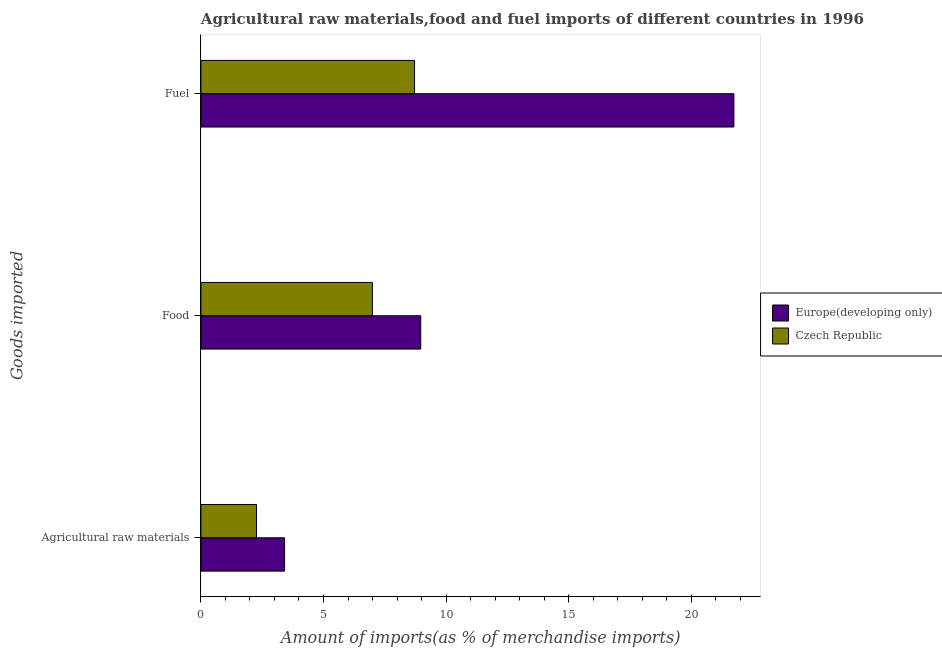Are the number of bars per tick equal to the number of legend labels?
Your answer should be very brief. Yes. Are the number of bars on each tick of the Y-axis equal?
Provide a succinct answer. Yes. What is the label of the 1st group of bars from the top?
Offer a very short reply. Fuel. What is the percentage of raw materials imports in Czech Republic?
Offer a very short reply. 2.27. Across all countries, what is the maximum percentage of fuel imports?
Provide a short and direct response. 21.74. Across all countries, what is the minimum percentage of raw materials imports?
Keep it short and to the point. 2.27. In which country was the percentage of food imports maximum?
Offer a terse response. Europe(developing only). In which country was the percentage of food imports minimum?
Offer a terse response. Czech Republic. What is the total percentage of fuel imports in the graph?
Provide a short and direct response. 30.45. What is the difference between the percentage of fuel imports in Europe(developing only) and that in Czech Republic?
Your answer should be compact. 13.03. What is the difference between the percentage of fuel imports in Czech Republic and the percentage of food imports in Europe(developing only)?
Give a very brief answer. -0.25. What is the average percentage of food imports per country?
Your response must be concise. 7.98. What is the difference between the percentage of food imports and percentage of raw materials imports in Europe(developing only)?
Your answer should be very brief. 5.55. What is the ratio of the percentage of food imports in Europe(developing only) to that in Czech Republic?
Provide a succinct answer. 1.28. Is the percentage of fuel imports in Czech Republic less than that in Europe(developing only)?
Ensure brevity in your answer.  Yes. Is the difference between the percentage of food imports in Czech Republic and Europe(developing only) greater than the difference between the percentage of raw materials imports in Czech Republic and Europe(developing only)?
Provide a succinct answer. No. What is the difference between the highest and the second highest percentage of fuel imports?
Give a very brief answer. 13.03. What is the difference between the highest and the lowest percentage of food imports?
Provide a succinct answer. 1.97. In how many countries, is the percentage of fuel imports greater than the average percentage of fuel imports taken over all countries?
Offer a very short reply. 1. Is the sum of the percentage of food imports in Europe(developing only) and Czech Republic greater than the maximum percentage of raw materials imports across all countries?
Make the answer very short. Yes. What does the 2nd bar from the top in Fuel represents?
Ensure brevity in your answer.  Europe(developing only). What does the 2nd bar from the bottom in Food represents?
Make the answer very short. Czech Republic. Are all the bars in the graph horizontal?
Provide a short and direct response. Yes. How many countries are there in the graph?
Offer a terse response. 2. What is the difference between two consecutive major ticks on the X-axis?
Provide a succinct answer. 5. Are the values on the major ticks of X-axis written in scientific E-notation?
Ensure brevity in your answer.  No. Does the graph contain any zero values?
Give a very brief answer. No. Does the graph contain grids?
Offer a very short reply. No. How many legend labels are there?
Provide a short and direct response. 2. What is the title of the graph?
Your response must be concise. Agricultural raw materials,food and fuel imports of different countries in 1996. What is the label or title of the X-axis?
Make the answer very short. Amount of imports(as % of merchandise imports). What is the label or title of the Y-axis?
Your response must be concise. Goods imported. What is the Amount of imports(as % of merchandise imports) of Europe(developing only) in Agricultural raw materials?
Offer a terse response. 3.41. What is the Amount of imports(as % of merchandise imports) of Czech Republic in Agricultural raw materials?
Keep it short and to the point. 2.27. What is the Amount of imports(as % of merchandise imports) in Europe(developing only) in Food?
Offer a very short reply. 8.97. What is the Amount of imports(as % of merchandise imports) in Czech Republic in Food?
Give a very brief answer. 6.99. What is the Amount of imports(as % of merchandise imports) in Europe(developing only) in Fuel?
Offer a terse response. 21.74. What is the Amount of imports(as % of merchandise imports) in Czech Republic in Fuel?
Make the answer very short. 8.71. Across all Goods imported, what is the maximum Amount of imports(as % of merchandise imports) in Europe(developing only)?
Provide a succinct answer. 21.74. Across all Goods imported, what is the maximum Amount of imports(as % of merchandise imports) of Czech Republic?
Ensure brevity in your answer.  8.71. Across all Goods imported, what is the minimum Amount of imports(as % of merchandise imports) in Europe(developing only)?
Make the answer very short. 3.41. Across all Goods imported, what is the minimum Amount of imports(as % of merchandise imports) in Czech Republic?
Offer a terse response. 2.27. What is the total Amount of imports(as % of merchandise imports) in Europe(developing only) in the graph?
Offer a terse response. 34.12. What is the total Amount of imports(as % of merchandise imports) in Czech Republic in the graph?
Offer a very short reply. 17.98. What is the difference between the Amount of imports(as % of merchandise imports) in Europe(developing only) in Agricultural raw materials and that in Food?
Ensure brevity in your answer.  -5.55. What is the difference between the Amount of imports(as % of merchandise imports) of Czech Republic in Agricultural raw materials and that in Food?
Your answer should be very brief. -4.73. What is the difference between the Amount of imports(as % of merchandise imports) in Europe(developing only) in Agricultural raw materials and that in Fuel?
Ensure brevity in your answer.  -18.33. What is the difference between the Amount of imports(as % of merchandise imports) in Czech Republic in Agricultural raw materials and that in Fuel?
Offer a very short reply. -6.45. What is the difference between the Amount of imports(as % of merchandise imports) in Europe(developing only) in Food and that in Fuel?
Give a very brief answer. -12.77. What is the difference between the Amount of imports(as % of merchandise imports) in Czech Republic in Food and that in Fuel?
Your answer should be compact. -1.72. What is the difference between the Amount of imports(as % of merchandise imports) in Europe(developing only) in Agricultural raw materials and the Amount of imports(as % of merchandise imports) in Czech Republic in Food?
Your response must be concise. -3.58. What is the difference between the Amount of imports(as % of merchandise imports) in Europe(developing only) in Agricultural raw materials and the Amount of imports(as % of merchandise imports) in Czech Republic in Fuel?
Your response must be concise. -5.3. What is the difference between the Amount of imports(as % of merchandise imports) in Europe(developing only) in Food and the Amount of imports(as % of merchandise imports) in Czech Republic in Fuel?
Offer a terse response. 0.25. What is the average Amount of imports(as % of merchandise imports) in Europe(developing only) per Goods imported?
Give a very brief answer. 11.37. What is the average Amount of imports(as % of merchandise imports) in Czech Republic per Goods imported?
Make the answer very short. 5.99. What is the difference between the Amount of imports(as % of merchandise imports) of Europe(developing only) and Amount of imports(as % of merchandise imports) of Czech Republic in Agricultural raw materials?
Your answer should be compact. 1.14. What is the difference between the Amount of imports(as % of merchandise imports) of Europe(developing only) and Amount of imports(as % of merchandise imports) of Czech Republic in Food?
Your response must be concise. 1.97. What is the difference between the Amount of imports(as % of merchandise imports) in Europe(developing only) and Amount of imports(as % of merchandise imports) in Czech Republic in Fuel?
Keep it short and to the point. 13.03. What is the ratio of the Amount of imports(as % of merchandise imports) in Europe(developing only) in Agricultural raw materials to that in Food?
Your response must be concise. 0.38. What is the ratio of the Amount of imports(as % of merchandise imports) in Czech Republic in Agricultural raw materials to that in Food?
Your answer should be very brief. 0.32. What is the ratio of the Amount of imports(as % of merchandise imports) in Europe(developing only) in Agricultural raw materials to that in Fuel?
Provide a succinct answer. 0.16. What is the ratio of the Amount of imports(as % of merchandise imports) in Czech Republic in Agricultural raw materials to that in Fuel?
Your answer should be compact. 0.26. What is the ratio of the Amount of imports(as % of merchandise imports) of Europe(developing only) in Food to that in Fuel?
Offer a terse response. 0.41. What is the ratio of the Amount of imports(as % of merchandise imports) of Czech Republic in Food to that in Fuel?
Ensure brevity in your answer.  0.8. What is the difference between the highest and the second highest Amount of imports(as % of merchandise imports) in Europe(developing only)?
Provide a short and direct response. 12.77. What is the difference between the highest and the second highest Amount of imports(as % of merchandise imports) in Czech Republic?
Your response must be concise. 1.72. What is the difference between the highest and the lowest Amount of imports(as % of merchandise imports) in Europe(developing only)?
Provide a short and direct response. 18.33. What is the difference between the highest and the lowest Amount of imports(as % of merchandise imports) in Czech Republic?
Keep it short and to the point. 6.45. 